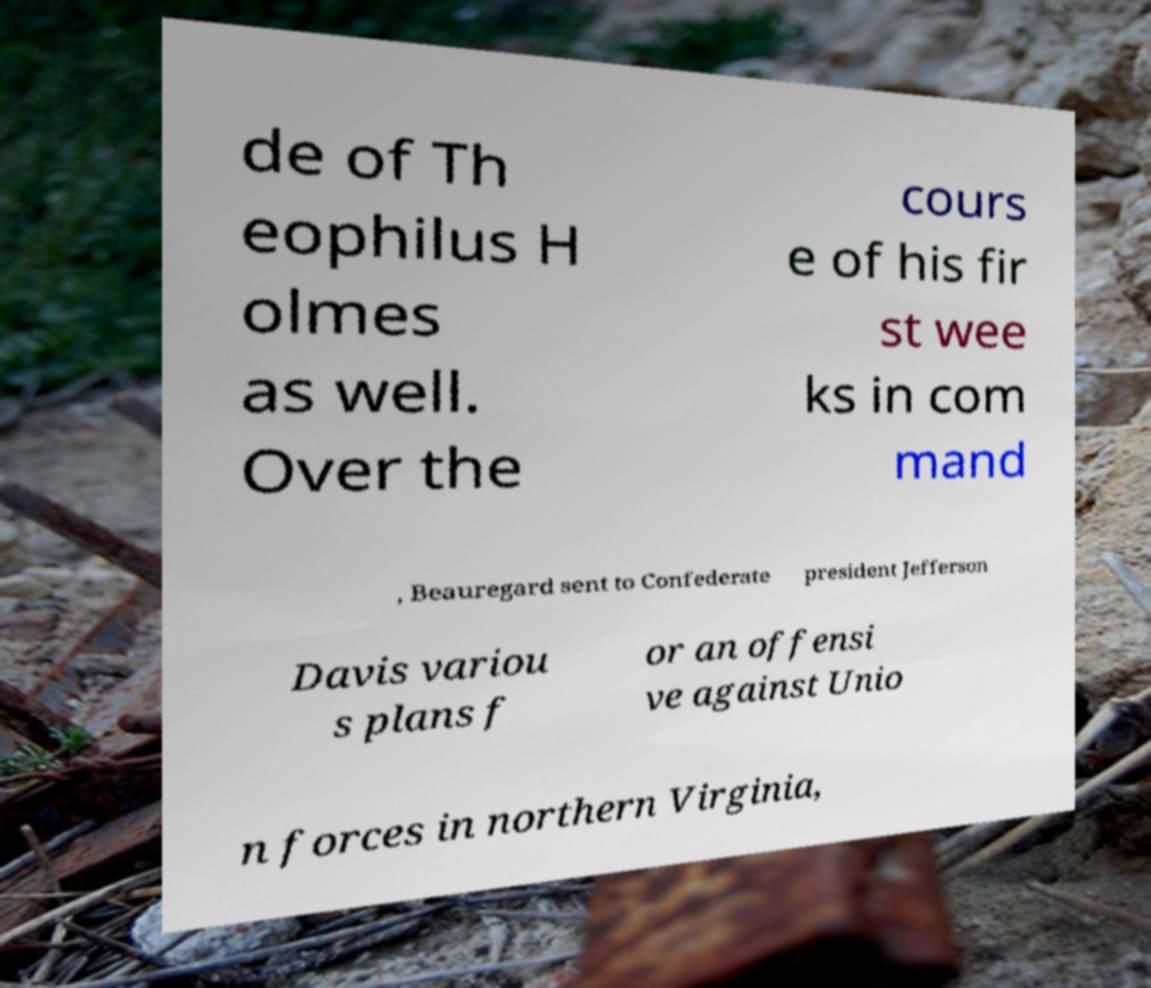Can you read and provide the text displayed in the image?This photo seems to have some interesting text. Can you extract and type it out for me? de of Th eophilus H olmes as well. Over the cours e of his fir st wee ks in com mand , Beauregard sent to Confederate president Jefferson Davis variou s plans f or an offensi ve against Unio n forces in northern Virginia, 